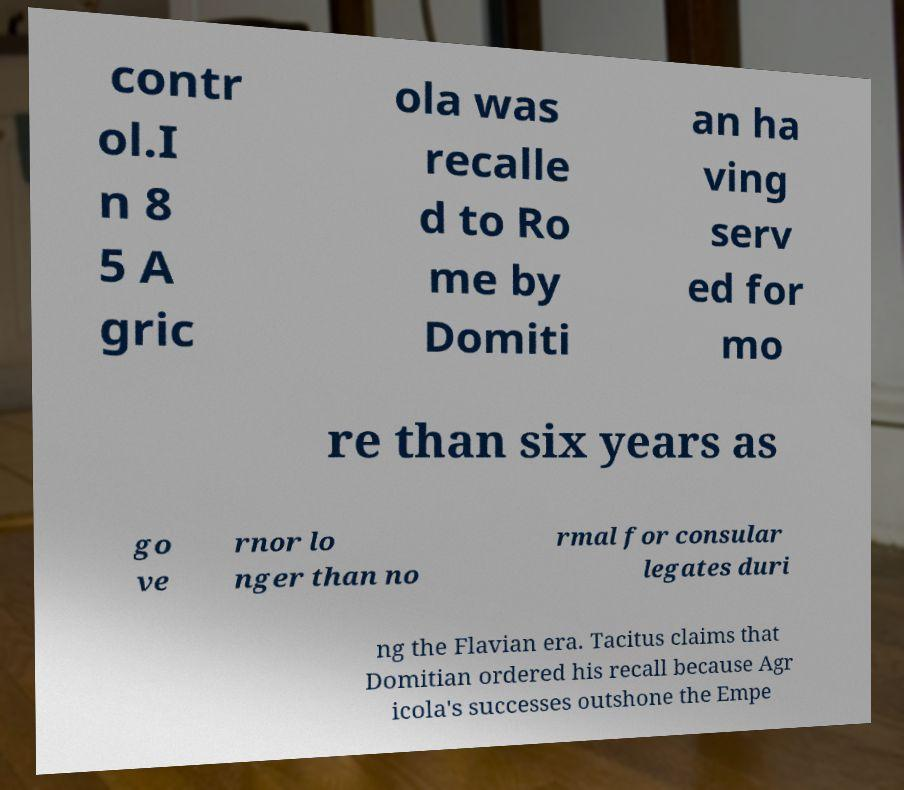I need the written content from this picture converted into text. Can you do that? contr ol.I n 8 5 A gric ola was recalle d to Ro me by Domiti an ha ving serv ed for mo re than six years as go ve rnor lo nger than no rmal for consular legates duri ng the Flavian era. Tacitus claims that Domitian ordered his recall because Agr icola's successes outshone the Empe 